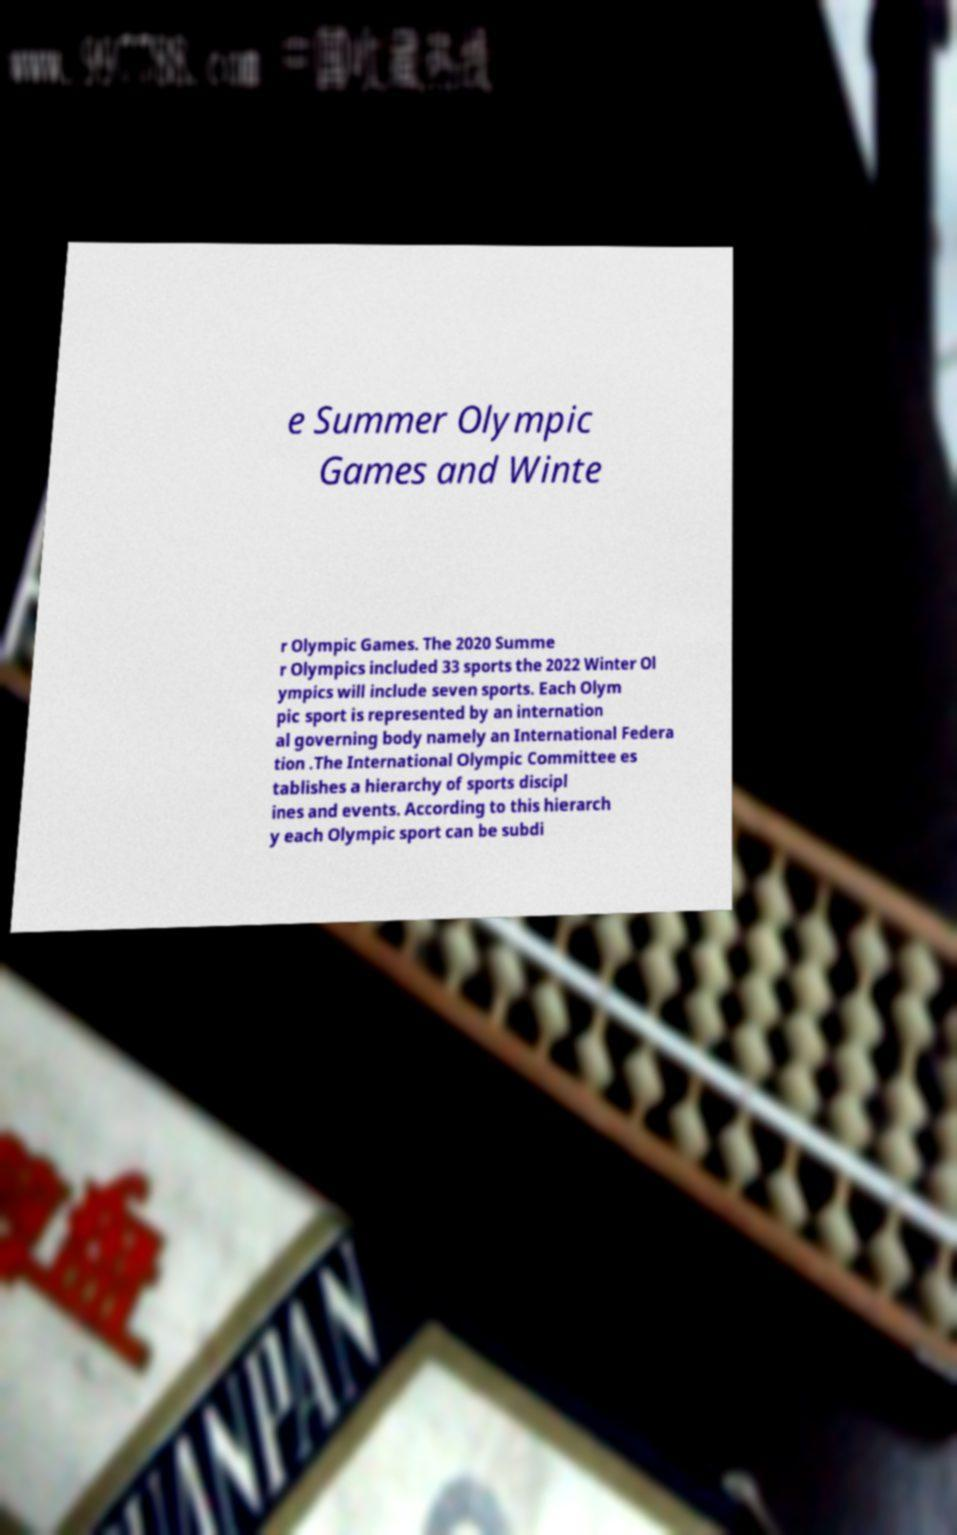Can you accurately transcribe the text from the provided image for me? e Summer Olympic Games and Winte r Olympic Games. The 2020 Summe r Olympics included 33 sports the 2022 Winter Ol ympics will include seven sports. Each Olym pic sport is represented by an internation al governing body namely an International Federa tion .The International Olympic Committee es tablishes a hierarchy of sports discipl ines and events. According to this hierarch y each Olympic sport can be subdi 